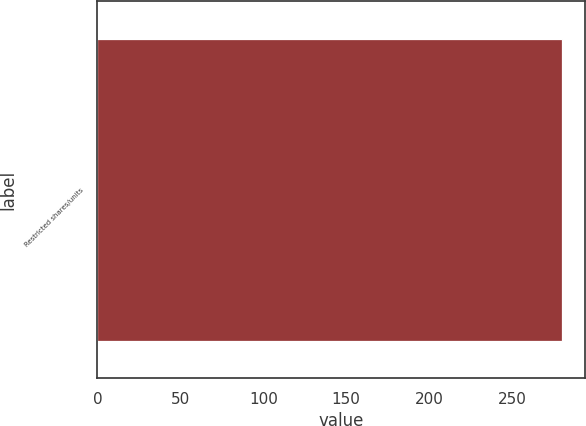Convert chart to OTSL. <chart><loc_0><loc_0><loc_500><loc_500><bar_chart><fcel>Restricted shares/units<nl><fcel>280<nl></chart> 